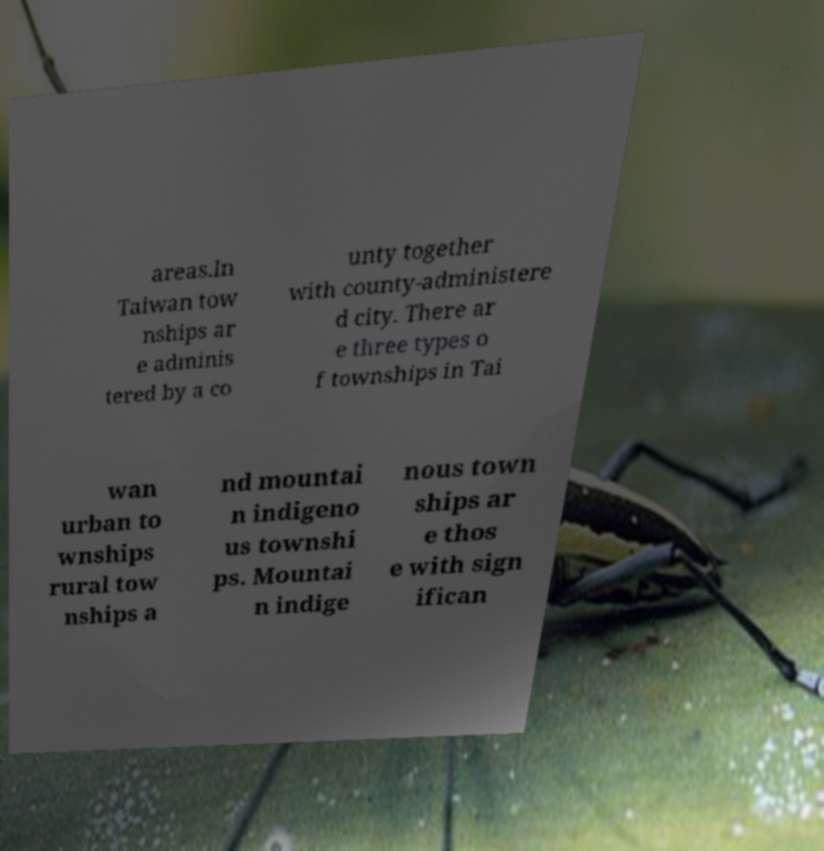Can you read and provide the text displayed in the image?This photo seems to have some interesting text. Can you extract and type it out for me? areas.In Taiwan tow nships ar e adminis tered by a co unty together with county-administere d city. There ar e three types o f townships in Tai wan urban to wnships rural tow nships a nd mountai n indigeno us townshi ps. Mountai n indige nous town ships ar e thos e with sign ifican 